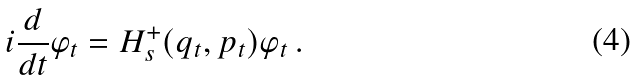<formula> <loc_0><loc_0><loc_500><loc_500>i \frac { d } { d t } \varphi _ { t } = H _ { s } ^ { + } ( q _ { t } , p _ { t } ) \varphi _ { t } \, .</formula> 